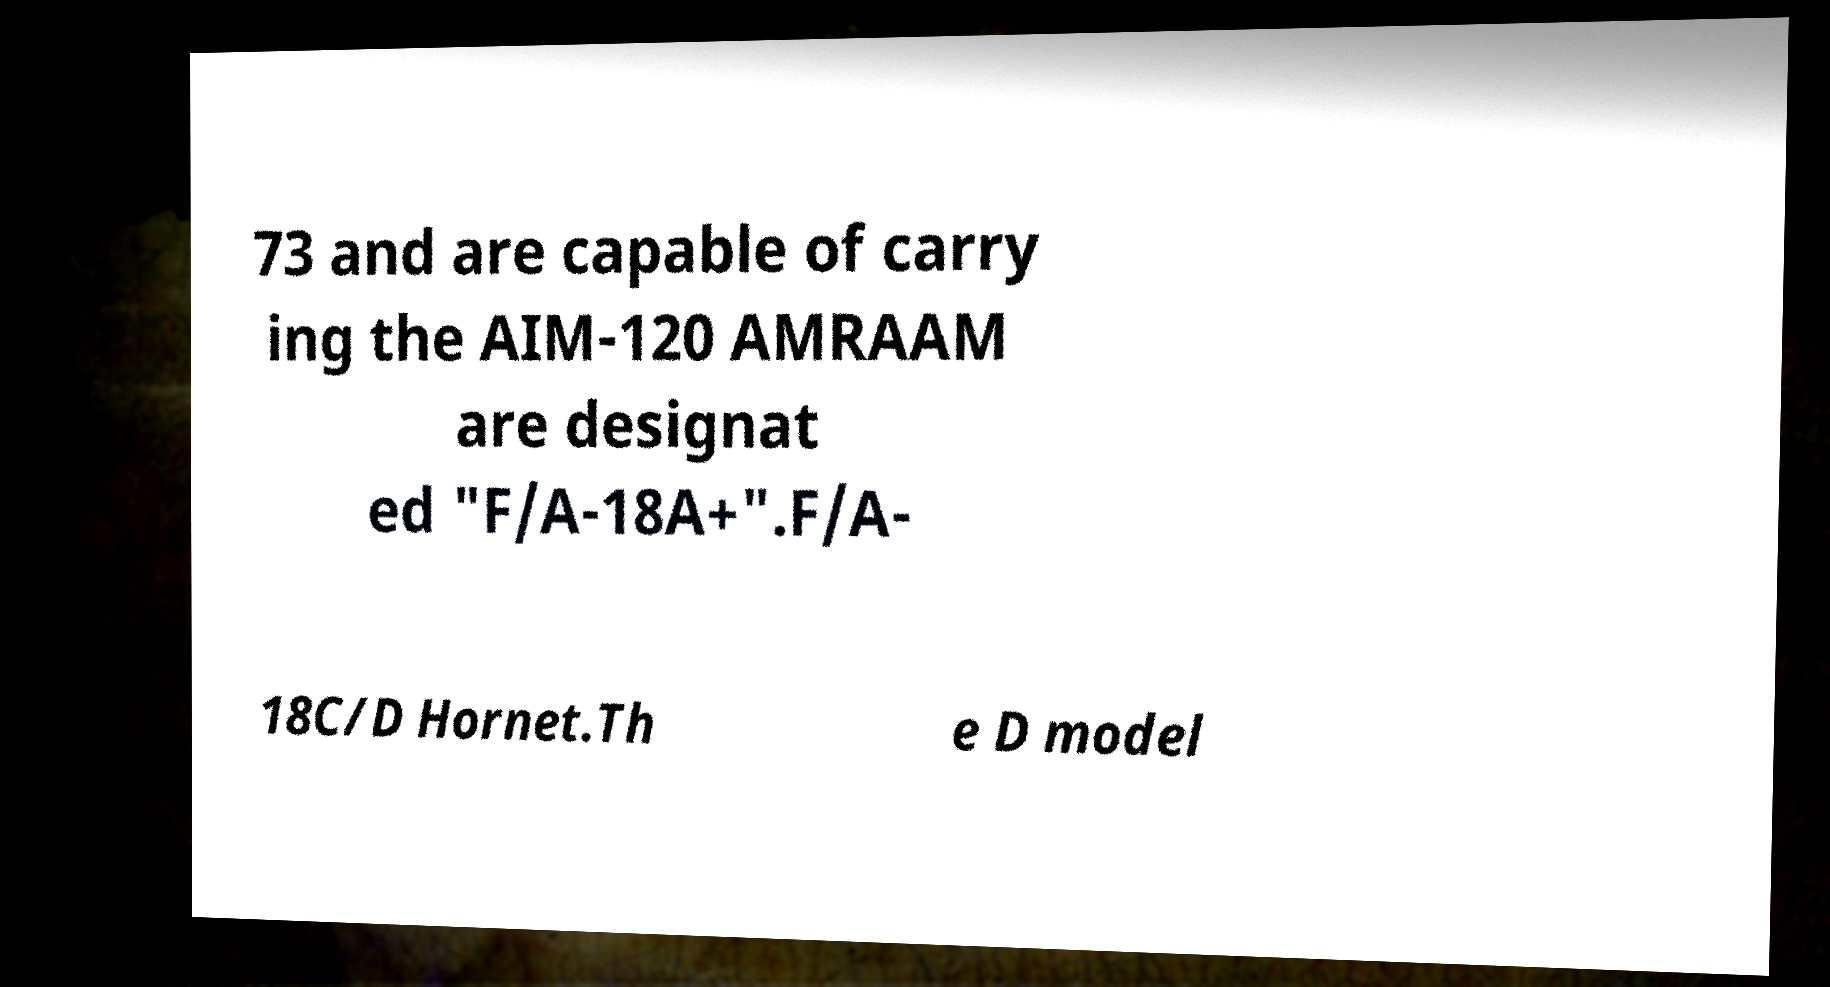Can you accurately transcribe the text from the provided image for me? 73 and are capable of carry ing the AIM-120 AMRAAM are designat ed "F/A-18A+".F/A- 18C/D Hornet.Th e D model 